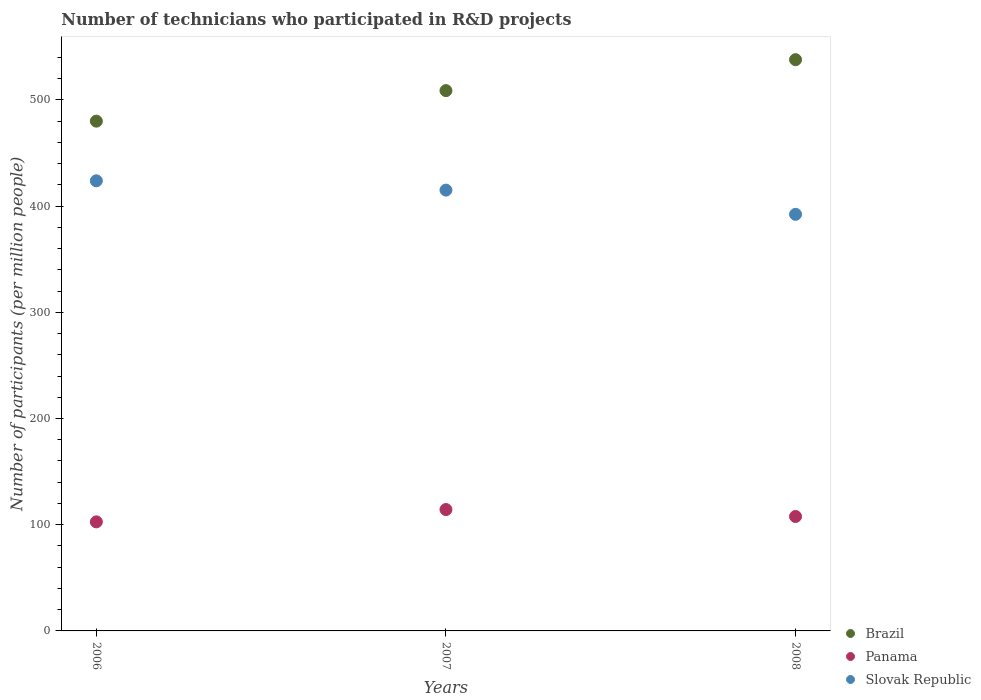What is the number of technicians who participated in R&D projects in Slovak Republic in 2007?
Keep it short and to the point. 415.06. Across all years, what is the maximum number of technicians who participated in R&D projects in Panama?
Make the answer very short. 114.3. Across all years, what is the minimum number of technicians who participated in R&D projects in Slovak Republic?
Your answer should be very brief. 392.28. In which year was the number of technicians who participated in R&D projects in Panama maximum?
Provide a short and direct response. 2007. What is the total number of technicians who participated in R&D projects in Slovak Republic in the graph?
Give a very brief answer. 1231.17. What is the difference between the number of technicians who participated in R&D projects in Slovak Republic in 2007 and that in 2008?
Offer a terse response. 22.79. What is the difference between the number of technicians who participated in R&D projects in Panama in 2007 and the number of technicians who participated in R&D projects in Slovak Republic in 2008?
Provide a succinct answer. -277.98. What is the average number of technicians who participated in R&D projects in Slovak Republic per year?
Give a very brief answer. 410.39. In the year 2007, what is the difference between the number of technicians who participated in R&D projects in Brazil and number of technicians who participated in R&D projects in Panama?
Your answer should be compact. 394.45. In how many years, is the number of technicians who participated in R&D projects in Brazil greater than 420?
Offer a terse response. 3. What is the ratio of the number of technicians who participated in R&D projects in Slovak Republic in 2006 to that in 2008?
Offer a terse response. 1.08. Is the number of technicians who participated in R&D projects in Slovak Republic in 2007 less than that in 2008?
Give a very brief answer. No. What is the difference between the highest and the second highest number of technicians who participated in R&D projects in Brazil?
Your answer should be compact. 29.13. What is the difference between the highest and the lowest number of technicians who participated in R&D projects in Brazil?
Provide a succinct answer. 57.88. In how many years, is the number of technicians who participated in R&D projects in Slovak Republic greater than the average number of technicians who participated in R&D projects in Slovak Republic taken over all years?
Your answer should be compact. 2. Is the sum of the number of technicians who participated in R&D projects in Slovak Republic in 2006 and 2007 greater than the maximum number of technicians who participated in R&D projects in Brazil across all years?
Your answer should be very brief. Yes. Does the number of technicians who participated in R&D projects in Panama monotonically increase over the years?
Give a very brief answer. No. Is the number of technicians who participated in R&D projects in Panama strictly greater than the number of technicians who participated in R&D projects in Brazil over the years?
Your response must be concise. No. Is the number of technicians who participated in R&D projects in Slovak Republic strictly less than the number of technicians who participated in R&D projects in Panama over the years?
Keep it short and to the point. No. How many dotlines are there?
Provide a short and direct response. 3. What is the difference between two consecutive major ticks on the Y-axis?
Provide a short and direct response. 100. Does the graph contain any zero values?
Offer a very short reply. No. How many legend labels are there?
Keep it short and to the point. 3. How are the legend labels stacked?
Your response must be concise. Vertical. What is the title of the graph?
Your answer should be very brief. Number of technicians who participated in R&D projects. What is the label or title of the Y-axis?
Provide a short and direct response. Number of participants (per million people). What is the Number of participants (per million people) of Brazil in 2006?
Offer a terse response. 480. What is the Number of participants (per million people) in Panama in 2006?
Offer a very short reply. 102.71. What is the Number of participants (per million people) of Slovak Republic in 2006?
Give a very brief answer. 423.83. What is the Number of participants (per million people) in Brazil in 2007?
Offer a very short reply. 508.75. What is the Number of participants (per million people) in Panama in 2007?
Your answer should be compact. 114.3. What is the Number of participants (per million people) of Slovak Republic in 2007?
Your answer should be very brief. 415.06. What is the Number of participants (per million people) of Brazil in 2008?
Offer a very short reply. 537.88. What is the Number of participants (per million people) of Panama in 2008?
Your answer should be compact. 107.75. What is the Number of participants (per million people) in Slovak Republic in 2008?
Your response must be concise. 392.28. Across all years, what is the maximum Number of participants (per million people) in Brazil?
Offer a terse response. 537.88. Across all years, what is the maximum Number of participants (per million people) of Panama?
Your answer should be very brief. 114.3. Across all years, what is the maximum Number of participants (per million people) in Slovak Republic?
Offer a terse response. 423.83. Across all years, what is the minimum Number of participants (per million people) of Brazil?
Your response must be concise. 480. Across all years, what is the minimum Number of participants (per million people) in Panama?
Give a very brief answer. 102.71. Across all years, what is the minimum Number of participants (per million people) of Slovak Republic?
Make the answer very short. 392.28. What is the total Number of participants (per million people) of Brazil in the graph?
Offer a terse response. 1526.64. What is the total Number of participants (per million people) in Panama in the graph?
Your answer should be compact. 324.76. What is the total Number of participants (per million people) of Slovak Republic in the graph?
Ensure brevity in your answer.  1231.17. What is the difference between the Number of participants (per million people) in Brazil in 2006 and that in 2007?
Provide a short and direct response. -28.74. What is the difference between the Number of participants (per million people) of Panama in 2006 and that in 2007?
Provide a succinct answer. -11.59. What is the difference between the Number of participants (per million people) in Slovak Republic in 2006 and that in 2007?
Your response must be concise. 8.77. What is the difference between the Number of participants (per million people) of Brazil in 2006 and that in 2008?
Your answer should be compact. -57.88. What is the difference between the Number of participants (per million people) of Panama in 2006 and that in 2008?
Offer a very short reply. -5.05. What is the difference between the Number of participants (per million people) in Slovak Republic in 2006 and that in 2008?
Provide a short and direct response. 31.56. What is the difference between the Number of participants (per million people) in Brazil in 2007 and that in 2008?
Ensure brevity in your answer.  -29.13. What is the difference between the Number of participants (per million people) of Panama in 2007 and that in 2008?
Provide a succinct answer. 6.54. What is the difference between the Number of participants (per million people) in Slovak Republic in 2007 and that in 2008?
Your answer should be compact. 22.79. What is the difference between the Number of participants (per million people) of Brazil in 2006 and the Number of participants (per million people) of Panama in 2007?
Offer a very short reply. 365.71. What is the difference between the Number of participants (per million people) of Brazil in 2006 and the Number of participants (per million people) of Slovak Republic in 2007?
Ensure brevity in your answer.  64.94. What is the difference between the Number of participants (per million people) of Panama in 2006 and the Number of participants (per million people) of Slovak Republic in 2007?
Provide a short and direct response. -312.36. What is the difference between the Number of participants (per million people) in Brazil in 2006 and the Number of participants (per million people) in Panama in 2008?
Your answer should be very brief. 372.25. What is the difference between the Number of participants (per million people) in Brazil in 2006 and the Number of participants (per million people) in Slovak Republic in 2008?
Your answer should be very brief. 87.73. What is the difference between the Number of participants (per million people) in Panama in 2006 and the Number of participants (per million people) in Slovak Republic in 2008?
Give a very brief answer. -289.57. What is the difference between the Number of participants (per million people) in Brazil in 2007 and the Number of participants (per million people) in Panama in 2008?
Provide a short and direct response. 400.99. What is the difference between the Number of participants (per million people) in Brazil in 2007 and the Number of participants (per million people) in Slovak Republic in 2008?
Offer a terse response. 116.47. What is the difference between the Number of participants (per million people) in Panama in 2007 and the Number of participants (per million people) in Slovak Republic in 2008?
Offer a very short reply. -277.98. What is the average Number of participants (per million people) in Brazil per year?
Provide a succinct answer. 508.88. What is the average Number of participants (per million people) in Panama per year?
Your answer should be very brief. 108.25. What is the average Number of participants (per million people) in Slovak Republic per year?
Ensure brevity in your answer.  410.39. In the year 2006, what is the difference between the Number of participants (per million people) of Brazil and Number of participants (per million people) of Panama?
Offer a very short reply. 377.3. In the year 2006, what is the difference between the Number of participants (per million people) in Brazil and Number of participants (per million people) in Slovak Republic?
Give a very brief answer. 56.17. In the year 2006, what is the difference between the Number of participants (per million people) in Panama and Number of participants (per million people) in Slovak Republic?
Give a very brief answer. -321.13. In the year 2007, what is the difference between the Number of participants (per million people) of Brazil and Number of participants (per million people) of Panama?
Your answer should be very brief. 394.45. In the year 2007, what is the difference between the Number of participants (per million people) of Brazil and Number of participants (per million people) of Slovak Republic?
Provide a succinct answer. 93.69. In the year 2007, what is the difference between the Number of participants (per million people) of Panama and Number of participants (per million people) of Slovak Republic?
Provide a short and direct response. -300.76. In the year 2008, what is the difference between the Number of participants (per million people) of Brazil and Number of participants (per million people) of Panama?
Your answer should be very brief. 430.13. In the year 2008, what is the difference between the Number of participants (per million people) in Brazil and Number of participants (per million people) in Slovak Republic?
Your answer should be compact. 145.61. In the year 2008, what is the difference between the Number of participants (per million people) of Panama and Number of participants (per million people) of Slovak Republic?
Provide a short and direct response. -284.52. What is the ratio of the Number of participants (per million people) in Brazil in 2006 to that in 2007?
Make the answer very short. 0.94. What is the ratio of the Number of participants (per million people) of Panama in 2006 to that in 2007?
Keep it short and to the point. 0.9. What is the ratio of the Number of participants (per million people) in Slovak Republic in 2006 to that in 2007?
Your answer should be compact. 1.02. What is the ratio of the Number of participants (per million people) of Brazil in 2006 to that in 2008?
Your answer should be very brief. 0.89. What is the ratio of the Number of participants (per million people) of Panama in 2006 to that in 2008?
Make the answer very short. 0.95. What is the ratio of the Number of participants (per million people) of Slovak Republic in 2006 to that in 2008?
Your answer should be very brief. 1.08. What is the ratio of the Number of participants (per million people) in Brazil in 2007 to that in 2008?
Offer a very short reply. 0.95. What is the ratio of the Number of participants (per million people) of Panama in 2007 to that in 2008?
Make the answer very short. 1.06. What is the ratio of the Number of participants (per million people) of Slovak Republic in 2007 to that in 2008?
Keep it short and to the point. 1.06. What is the difference between the highest and the second highest Number of participants (per million people) of Brazil?
Provide a short and direct response. 29.13. What is the difference between the highest and the second highest Number of participants (per million people) in Panama?
Provide a short and direct response. 6.54. What is the difference between the highest and the second highest Number of participants (per million people) of Slovak Republic?
Offer a terse response. 8.77. What is the difference between the highest and the lowest Number of participants (per million people) in Brazil?
Your answer should be very brief. 57.88. What is the difference between the highest and the lowest Number of participants (per million people) of Panama?
Your answer should be very brief. 11.59. What is the difference between the highest and the lowest Number of participants (per million people) of Slovak Republic?
Offer a very short reply. 31.56. 